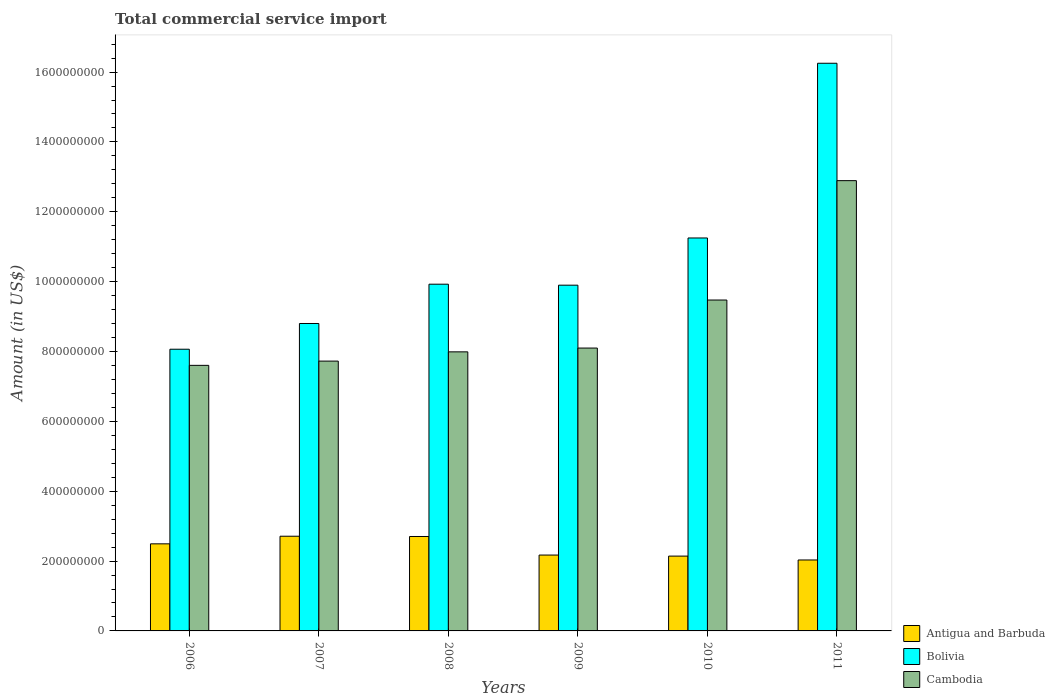How many different coloured bars are there?
Ensure brevity in your answer.  3. How many bars are there on the 5th tick from the left?
Your answer should be very brief. 3. What is the total commercial service import in Bolivia in 2006?
Offer a very short reply. 8.07e+08. Across all years, what is the maximum total commercial service import in Cambodia?
Offer a very short reply. 1.29e+09. Across all years, what is the minimum total commercial service import in Bolivia?
Make the answer very short. 8.07e+08. In which year was the total commercial service import in Bolivia maximum?
Your answer should be compact. 2011. In which year was the total commercial service import in Antigua and Barbuda minimum?
Your response must be concise. 2011. What is the total total commercial service import in Cambodia in the graph?
Give a very brief answer. 5.38e+09. What is the difference between the total commercial service import in Cambodia in 2009 and that in 2011?
Your response must be concise. -4.79e+08. What is the difference between the total commercial service import in Antigua and Barbuda in 2008 and the total commercial service import in Bolivia in 2011?
Make the answer very short. -1.35e+09. What is the average total commercial service import in Bolivia per year?
Provide a succinct answer. 1.07e+09. In the year 2006, what is the difference between the total commercial service import in Antigua and Barbuda and total commercial service import in Cambodia?
Offer a terse response. -5.11e+08. In how many years, is the total commercial service import in Bolivia greater than 1400000000 US$?
Make the answer very short. 1. What is the ratio of the total commercial service import in Bolivia in 2009 to that in 2010?
Your answer should be compact. 0.88. Is the difference between the total commercial service import in Antigua and Barbuda in 2008 and 2009 greater than the difference between the total commercial service import in Cambodia in 2008 and 2009?
Keep it short and to the point. Yes. What is the difference between the highest and the second highest total commercial service import in Antigua and Barbuda?
Your answer should be very brief. 7.73e+05. What is the difference between the highest and the lowest total commercial service import in Bolivia?
Keep it short and to the point. 8.19e+08. In how many years, is the total commercial service import in Bolivia greater than the average total commercial service import in Bolivia taken over all years?
Provide a short and direct response. 2. What does the 3rd bar from the left in 2008 represents?
Provide a succinct answer. Cambodia. What does the 1st bar from the right in 2010 represents?
Provide a succinct answer. Cambodia. Is it the case that in every year, the sum of the total commercial service import in Cambodia and total commercial service import in Bolivia is greater than the total commercial service import in Antigua and Barbuda?
Keep it short and to the point. Yes. Are all the bars in the graph horizontal?
Ensure brevity in your answer.  No. What is the difference between two consecutive major ticks on the Y-axis?
Your answer should be very brief. 2.00e+08. Are the values on the major ticks of Y-axis written in scientific E-notation?
Give a very brief answer. No. How many legend labels are there?
Provide a short and direct response. 3. How are the legend labels stacked?
Keep it short and to the point. Vertical. What is the title of the graph?
Provide a succinct answer. Total commercial service import. What is the label or title of the Y-axis?
Offer a terse response. Amount (in US$). What is the Amount (in US$) in Antigua and Barbuda in 2006?
Keep it short and to the point. 2.49e+08. What is the Amount (in US$) of Bolivia in 2006?
Ensure brevity in your answer.  8.07e+08. What is the Amount (in US$) of Cambodia in 2006?
Provide a short and direct response. 7.60e+08. What is the Amount (in US$) in Antigua and Barbuda in 2007?
Offer a terse response. 2.71e+08. What is the Amount (in US$) of Bolivia in 2007?
Your answer should be compact. 8.80e+08. What is the Amount (in US$) of Cambodia in 2007?
Offer a very short reply. 7.72e+08. What is the Amount (in US$) in Antigua and Barbuda in 2008?
Your response must be concise. 2.70e+08. What is the Amount (in US$) in Bolivia in 2008?
Your answer should be very brief. 9.93e+08. What is the Amount (in US$) of Cambodia in 2008?
Offer a very short reply. 7.99e+08. What is the Amount (in US$) of Antigua and Barbuda in 2009?
Your response must be concise. 2.17e+08. What is the Amount (in US$) of Bolivia in 2009?
Your response must be concise. 9.90e+08. What is the Amount (in US$) in Cambodia in 2009?
Your answer should be compact. 8.10e+08. What is the Amount (in US$) of Antigua and Barbuda in 2010?
Your response must be concise. 2.14e+08. What is the Amount (in US$) of Bolivia in 2010?
Provide a succinct answer. 1.13e+09. What is the Amount (in US$) in Cambodia in 2010?
Offer a very short reply. 9.47e+08. What is the Amount (in US$) in Antigua and Barbuda in 2011?
Provide a short and direct response. 2.03e+08. What is the Amount (in US$) in Bolivia in 2011?
Make the answer very short. 1.63e+09. What is the Amount (in US$) in Cambodia in 2011?
Your answer should be compact. 1.29e+09. Across all years, what is the maximum Amount (in US$) in Antigua and Barbuda?
Your answer should be very brief. 2.71e+08. Across all years, what is the maximum Amount (in US$) in Bolivia?
Make the answer very short. 1.63e+09. Across all years, what is the maximum Amount (in US$) of Cambodia?
Ensure brevity in your answer.  1.29e+09. Across all years, what is the minimum Amount (in US$) in Antigua and Barbuda?
Your response must be concise. 2.03e+08. Across all years, what is the minimum Amount (in US$) in Bolivia?
Give a very brief answer. 8.07e+08. Across all years, what is the minimum Amount (in US$) of Cambodia?
Provide a short and direct response. 7.60e+08. What is the total Amount (in US$) in Antigua and Barbuda in the graph?
Your answer should be compact. 1.43e+09. What is the total Amount (in US$) of Bolivia in the graph?
Make the answer very short. 6.42e+09. What is the total Amount (in US$) of Cambodia in the graph?
Give a very brief answer. 5.38e+09. What is the difference between the Amount (in US$) in Antigua and Barbuda in 2006 and that in 2007?
Make the answer very short. -2.18e+07. What is the difference between the Amount (in US$) of Bolivia in 2006 and that in 2007?
Offer a very short reply. -7.36e+07. What is the difference between the Amount (in US$) in Cambodia in 2006 and that in 2007?
Give a very brief answer. -1.21e+07. What is the difference between the Amount (in US$) of Antigua and Barbuda in 2006 and that in 2008?
Offer a very short reply. -2.10e+07. What is the difference between the Amount (in US$) in Bolivia in 2006 and that in 2008?
Your answer should be very brief. -1.86e+08. What is the difference between the Amount (in US$) of Cambodia in 2006 and that in 2008?
Your response must be concise. -3.86e+07. What is the difference between the Amount (in US$) of Antigua and Barbuda in 2006 and that in 2009?
Ensure brevity in your answer.  3.21e+07. What is the difference between the Amount (in US$) in Bolivia in 2006 and that in 2009?
Give a very brief answer. -1.83e+08. What is the difference between the Amount (in US$) of Cambodia in 2006 and that in 2009?
Offer a very short reply. -4.95e+07. What is the difference between the Amount (in US$) in Antigua and Barbuda in 2006 and that in 2010?
Offer a very short reply. 3.51e+07. What is the difference between the Amount (in US$) in Bolivia in 2006 and that in 2010?
Provide a succinct answer. -3.18e+08. What is the difference between the Amount (in US$) in Cambodia in 2006 and that in 2010?
Keep it short and to the point. -1.87e+08. What is the difference between the Amount (in US$) in Antigua and Barbuda in 2006 and that in 2011?
Offer a terse response. 4.62e+07. What is the difference between the Amount (in US$) of Bolivia in 2006 and that in 2011?
Give a very brief answer. -8.19e+08. What is the difference between the Amount (in US$) of Cambodia in 2006 and that in 2011?
Your answer should be compact. -5.29e+08. What is the difference between the Amount (in US$) of Antigua and Barbuda in 2007 and that in 2008?
Keep it short and to the point. 7.73e+05. What is the difference between the Amount (in US$) of Bolivia in 2007 and that in 2008?
Offer a terse response. -1.13e+08. What is the difference between the Amount (in US$) of Cambodia in 2007 and that in 2008?
Provide a short and direct response. -2.65e+07. What is the difference between the Amount (in US$) in Antigua and Barbuda in 2007 and that in 2009?
Your response must be concise. 5.39e+07. What is the difference between the Amount (in US$) of Bolivia in 2007 and that in 2009?
Ensure brevity in your answer.  -1.10e+08. What is the difference between the Amount (in US$) in Cambodia in 2007 and that in 2009?
Offer a terse response. -3.74e+07. What is the difference between the Amount (in US$) in Antigua and Barbuda in 2007 and that in 2010?
Your answer should be compact. 5.69e+07. What is the difference between the Amount (in US$) in Bolivia in 2007 and that in 2010?
Keep it short and to the point. -2.45e+08. What is the difference between the Amount (in US$) of Cambodia in 2007 and that in 2010?
Ensure brevity in your answer.  -1.75e+08. What is the difference between the Amount (in US$) of Antigua and Barbuda in 2007 and that in 2011?
Offer a very short reply. 6.80e+07. What is the difference between the Amount (in US$) of Bolivia in 2007 and that in 2011?
Give a very brief answer. -7.45e+08. What is the difference between the Amount (in US$) of Cambodia in 2007 and that in 2011?
Give a very brief answer. -5.17e+08. What is the difference between the Amount (in US$) in Antigua and Barbuda in 2008 and that in 2009?
Your answer should be very brief. 5.31e+07. What is the difference between the Amount (in US$) in Bolivia in 2008 and that in 2009?
Your answer should be compact. 2.86e+06. What is the difference between the Amount (in US$) of Cambodia in 2008 and that in 2009?
Ensure brevity in your answer.  -1.09e+07. What is the difference between the Amount (in US$) in Antigua and Barbuda in 2008 and that in 2010?
Make the answer very short. 5.61e+07. What is the difference between the Amount (in US$) in Bolivia in 2008 and that in 2010?
Offer a terse response. -1.32e+08. What is the difference between the Amount (in US$) in Cambodia in 2008 and that in 2010?
Your answer should be compact. -1.48e+08. What is the difference between the Amount (in US$) in Antigua and Barbuda in 2008 and that in 2011?
Offer a very short reply. 6.72e+07. What is the difference between the Amount (in US$) in Bolivia in 2008 and that in 2011?
Give a very brief answer. -6.33e+08. What is the difference between the Amount (in US$) of Cambodia in 2008 and that in 2011?
Provide a succinct answer. -4.90e+08. What is the difference between the Amount (in US$) of Antigua and Barbuda in 2009 and that in 2010?
Provide a succinct answer. 2.99e+06. What is the difference between the Amount (in US$) of Bolivia in 2009 and that in 2010?
Offer a terse response. -1.35e+08. What is the difference between the Amount (in US$) of Cambodia in 2009 and that in 2010?
Ensure brevity in your answer.  -1.38e+08. What is the difference between the Amount (in US$) in Antigua and Barbuda in 2009 and that in 2011?
Keep it short and to the point. 1.41e+07. What is the difference between the Amount (in US$) in Bolivia in 2009 and that in 2011?
Your answer should be compact. -6.35e+08. What is the difference between the Amount (in US$) in Cambodia in 2009 and that in 2011?
Your answer should be compact. -4.79e+08. What is the difference between the Amount (in US$) in Antigua and Barbuda in 2010 and that in 2011?
Your answer should be compact. 1.11e+07. What is the difference between the Amount (in US$) of Bolivia in 2010 and that in 2011?
Provide a succinct answer. -5.00e+08. What is the difference between the Amount (in US$) in Cambodia in 2010 and that in 2011?
Give a very brief answer. -3.42e+08. What is the difference between the Amount (in US$) of Antigua and Barbuda in 2006 and the Amount (in US$) of Bolivia in 2007?
Your response must be concise. -6.31e+08. What is the difference between the Amount (in US$) in Antigua and Barbuda in 2006 and the Amount (in US$) in Cambodia in 2007?
Offer a terse response. -5.23e+08. What is the difference between the Amount (in US$) in Bolivia in 2006 and the Amount (in US$) in Cambodia in 2007?
Your answer should be very brief. 3.40e+07. What is the difference between the Amount (in US$) in Antigua and Barbuda in 2006 and the Amount (in US$) in Bolivia in 2008?
Give a very brief answer. -7.43e+08. What is the difference between the Amount (in US$) of Antigua and Barbuda in 2006 and the Amount (in US$) of Cambodia in 2008?
Your answer should be compact. -5.50e+08. What is the difference between the Amount (in US$) in Bolivia in 2006 and the Amount (in US$) in Cambodia in 2008?
Your response must be concise. 7.52e+06. What is the difference between the Amount (in US$) in Antigua and Barbuda in 2006 and the Amount (in US$) in Bolivia in 2009?
Make the answer very short. -7.41e+08. What is the difference between the Amount (in US$) in Antigua and Barbuda in 2006 and the Amount (in US$) in Cambodia in 2009?
Make the answer very short. -5.61e+08. What is the difference between the Amount (in US$) of Bolivia in 2006 and the Amount (in US$) of Cambodia in 2009?
Make the answer very short. -3.36e+06. What is the difference between the Amount (in US$) in Antigua and Barbuda in 2006 and the Amount (in US$) in Bolivia in 2010?
Your answer should be compact. -8.76e+08. What is the difference between the Amount (in US$) of Antigua and Barbuda in 2006 and the Amount (in US$) of Cambodia in 2010?
Your answer should be very brief. -6.98e+08. What is the difference between the Amount (in US$) of Bolivia in 2006 and the Amount (in US$) of Cambodia in 2010?
Your response must be concise. -1.41e+08. What is the difference between the Amount (in US$) in Antigua and Barbuda in 2006 and the Amount (in US$) in Bolivia in 2011?
Give a very brief answer. -1.38e+09. What is the difference between the Amount (in US$) of Antigua and Barbuda in 2006 and the Amount (in US$) of Cambodia in 2011?
Provide a short and direct response. -1.04e+09. What is the difference between the Amount (in US$) of Bolivia in 2006 and the Amount (in US$) of Cambodia in 2011?
Give a very brief answer. -4.83e+08. What is the difference between the Amount (in US$) of Antigua and Barbuda in 2007 and the Amount (in US$) of Bolivia in 2008?
Provide a succinct answer. -7.22e+08. What is the difference between the Amount (in US$) of Antigua and Barbuda in 2007 and the Amount (in US$) of Cambodia in 2008?
Offer a terse response. -5.28e+08. What is the difference between the Amount (in US$) in Bolivia in 2007 and the Amount (in US$) in Cambodia in 2008?
Keep it short and to the point. 8.12e+07. What is the difference between the Amount (in US$) in Antigua and Barbuda in 2007 and the Amount (in US$) in Bolivia in 2009?
Offer a terse response. -7.19e+08. What is the difference between the Amount (in US$) in Antigua and Barbuda in 2007 and the Amount (in US$) in Cambodia in 2009?
Ensure brevity in your answer.  -5.39e+08. What is the difference between the Amount (in US$) in Bolivia in 2007 and the Amount (in US$) in Cambodia in 2009?
Make the answer very short. 7.03e+07. What is the difference between the Amount (in US$) in Antigua and Barbuda in 2007 and the Amount (in US$) in Bolivia in 2010?
Ensure brevity in your answer.  -8.54e+08. What is the difference between the Amount (in US$) of Antigua and Barbuda in 2007 and the Amount (in US$) of Cambodia in 2010?
Offer a terse response. -6.76e+08. What is the difference between the Amount (in US$) in Bolivia in 2007 and the Amount (in US$) in Cambodia in 2010?
Your answer should be very brief. -6.72e+07. What is the difference between the Amount (in US$) of Antigua and Barbuda in 2007 and the Amount (in US$) of Bolivia in 2011?
Provide a succinct answer. -1.35e+09. What is the difference between the Amount (in US$) in Antigua and Barbuda in 2007 and the Amount (in US$) in Cambodia in 2011?
Your response must be concise. -1.02e+09. What is the difference between the Amount (in US$) of Bolivia in 2007 and the Amount (in US$) of Cambodia in 2011?
Give a very brief answer. -4.09e+08. What is the difference between the Amount (in US$) in Antigua and Barbuda in 2008 and the Amount (in US$) in Bolivia in 2009?
Offer a very short reply. -7.20e+08. What is the difference between the Amount (in US$) of Antigua and Barbuda in 2008 and the Amount (in US$) of Cambodia in 2009?
Offer a terse response. -5.40e+08. What is the difference between the Amount (in US$) in Bolivia in 2008 and the Amount (in US$) in Cambodia in 2009?
Offer a terse response. 1.83e+08. What is the difference between the Amount (in US$) of Antigua and Barbuda in 2008 and the Amount (in US$) of Bolivia in 2010?
Keep it short and to the point. -8.55e+08. What is the difference between the Amount (in US$) in Antigua and Barbuda in 2008 and the Amount (in US$) in Cambodia in 2010?
Give a very brief answer. -6.77e+08. What is the difference between the Amount (in US$) in Bolivia in 2008 and the Amount (in US$) in Cambodia in 2010?
Offer a very short reply. 4.53e+07. What is the difference between the Amount (in US$) of Antigua and Barbuda in 2008 and the Amount (in US$) of Bolivia in 2011?
Provide a succinct answer. -1.35e+09. What is the difference between the Amount (in US$) in Antigua and Barbuda in 2008 and the Amount (in US$) in Cambodia in 2011?
Offer a very short reply. -1.02e+09. What is the difference between the Amount (in US$) in Bolivia in 2008 and the Amount (in US$) in Cambodia in 2011?
Keep it short and to the point. -2.96e+08. What is the difference between the Amount (in US$) in Antigua and Barbuda in 2009 and the Amount (in US$) in Bolivia in 2010?
Your answer should be compact. -9.08e+08. What is the difference between the Amount (in US$) in Antigua and Barbuda in 2009 and the Amount (in US$) in Cambodia in 2010?
Ensure brevity in your answer.  -7.30e+08. What is the difference between the Amount (in US$) of Bolivia in 2009 and the Amount (in US$) of Cambodia in 2010?
Make the answer very short. 4.25e+07. What is the difference between the Amount (in US$) in Antigua and Barbuda in 2009 and the Amount (in US$) in Bolivia in 2011?
Your answer should be compact. -1.41e+09. What is the difference between the Amount (in US$) of Antigua and Barbuda in 2009 and the Amount (in US$) of Cambodia in 2011?
Provide a succinct answer. -1.07e+09. What is the difference between the Amount (in US$) of Bolivia in 2009 and the Amount (in US$) of Cambodia in 2011?
Your answer should be very brief. -2.99e+08. What is the difference between the Amount (in US$) of Antigua and Barbuda in 2010 and the Amount (in US$) of Bolivia in 2011?
Your response must be concise. -1.41e+09. What is the difference between the Amount (in US$) in Antigua and Barbuda in 2010 and the Amount (in US$) in Cambodia in 2011?
Your answer should be very brief. -1.07e+09. What is the difference between the Amount (in US$) in Bolivia in 2010 and the Amount (in US$) in Cambodia in 2011?
Your response must be concise. -1.64e+08. What is the average Amount (in US$) of Antigua and Barbuda per year?
Ensure brevity in your answer.  2.38e+08. What is the average Amount (in US$) in Bolivia per year?
Provide a short and direct response. 1.07e+09. What is the average Amount (in US$) in Cambodia per year?
Your response must be concise. 8.96e+08. In the year 2006, what is the difference between the Amount (in US$) of Antigua and Barbuda and Amount (in US$) of Bolivia?
Ensure brevity in your answer.  -5.57e+08. In the year 2006, what is the difference between the Amount (in US$) of Antigua and Barbuda and Amount (in US$) of Cambodia?
Provide a succinct answer. -5.11e+08. In the year 2006, what is the difference between the Amount (in US$) in Bolivia and Amount (in US$) in Cambodia?
Offer a very short reply. 4.62e+07. In the year 2007, what is the difference between the Amount (in US$) in Antigua and Barbuda and Amount (in US$) in Bolivia?
Keep it short and to the point. -6.09e+08. In the year 2007, what is the difference between the Amount (in US$) in Antigua and Barbuda and Amount (in US$) in Cambodia?
Your answer should be very brief. -5.01e+08. In the year 2007, what is the difference between the Amount (in US$) in Bolivia and Amount (in US$) in Cambodia?
Keep it short and to the point. 1.08e+08. In the year 2008, what is the difference between the Amount (in US$) of Antigua and Barbuda and Amount (in US$) of Bolivia?
Offer a terse response. -7.22e+08. In the year 2008, what is the difference between the Amount (in US$) of Antigua and Barbuda and Amount (in US$) of Cambodia?
Offer a very short reply. -5.29e+08. In the year 2008, what is the difference between the Amount (in US$) in Bolivia and Amount (in US$) in Cambodia?
Provide a succinct answer. 1.94e+08. In the year 2009, what is the difference between the Amount (in US$) in Antigua and Barbuda and Amount (in US$) in Bolivia?
Your response must be concise. -7.73e+08. In the year 2009, what is the difference between the Amount (in US$) of Antigua and Barbuda and Amount (in US$) of Cambodia?
Make the answer very short. -5.93e+08. In the year 2009, what is the difference between the Amount (in US$) of Bolivia and Amount (in US$) of Cambodia?
Keep it short and to the point. 1.80e+08. In the year 2010, what is the difference between the Amount (in US$) in Antigua and Barbuda and Amount (in US$) in Bolivia?
Your response must be concise. -9.11e+08. In the year 2010, what is the difference between the Amount (in US$) in Antigua and Barbuda and Amount (in US$) in Cambodia?
Offer a very short reply. -7.33e+08. In the year 2010, what is the difference between the Amount (in US$) of Bolivia and Amount (in US$) of Cambodia?
Provide a succinct answer. 1.78e+08. In the year 2011, what is the difference between the Amount (in US$) of Antigua and Barbuda and Amount (in US$) of Bolivia?
Ensure brevity in your answer.  -1.42e+09. In the year 2011, what is the difference between the Amount (in US$) in Antigua and Barbuda and Amount (in US$) in Cambodia?
Offer a terse response. -1.09e+09. In the year 2011, what is the difference between the Amount (in US$) of Bolivia and Amount (in US$) of Cambodia?
Keep it short and to the point. 3.36e+08. What is the ratio of the Amount (in US$) in Antigua and Barbuda in 2006 to that in 2007?
Provide a succinct answer. 0.92. What is the ratio of the Amount (in US$) of Bolivia in 2006 to that in 2007?
Provide a succinct answer. 0.92. What is the ratio of the Amount (in US$) of Cambodia in 2006 to that in 2007?
Your answer should be very brief. 0.98. What is the ratio of the Amount (in US$) of Antigua and Barbuda in 2006 to that in 2008?
Ensure brevity in your answer.  0.92. What is the ratio of the Amount (in US$) in Bolivia in 2006 to that in 2008?
Ensure brevity in your answer.  0.81. What is the ratio of the Amount (in US$) in Cambodia in 2006 to that in 2008?
Keep it short and to the point. 0.95. What is the ratio of the Amount (in US$) of Antigua and Barbuda in 2006 to that in 2009?
Provide a short and direct response. 1.15. What is the ratio of the Amount (in US$) in Bolivia in 2006 to that in 2009?
Offer a terse response. 0.81. What is the ratio of the Amount (in US$) of Cambodia in 2006 to that in 2009?
Your response must be concise. 0.94. What is the ratio of the Amount (in US$) in Antigua and Barbuda in 2006 to that in 2010?
Provide a short and direct response. 1.16. What is the ratio of the Amount (in US$) of Bolivia in 2006 to that in 2010?
Offer a very short reply. 0.72. What is the ratio of the Amount (in US$) of Cambodia in 2006 to that in 2010?
Make the answer very short. 0.8. What is the ratio of the Amount (in US$) in Antigua and Barbuda in 2006 to that in 2011?
Offer a very short reply. 1.23. What is the ratio of the Amount (in US$) in Bolivia in 2006 to that in 2011?
Keep it short and to the point. 0.5. What is the ratio of the Amount (in US$) of Cambodia in 2006 to that in 2011?
Give a very brief answer. 0.59. What is the ratio of the Amount (in US$) of Bolivia in 2007 to that in 2008?
Your response must be concise. 0.89. What is the ratio of the Amount (in US$) of Cambodia in 2007 to that in 2008?
Your answer should be very brief. 0.97. What is the ratio of the Amount (in US$) of Antigua and Barbuda in 2007 to that in 2009?
Your answer should be compact. 1.25. What is the ratio of the Amount (in US$) of Bolivia in 2007 to that in 2009?
Make the answer very short. 0.89. What is the ratio of the Amount (in US$) of Cambodia in 2007 to that in 2009?
Keep it short and to the point. 0.95. What is the ratio of the Amount (in US$) of Antigua and Barbuda in 2007 to that in 2010?
Offer a terse response. 1.27. What is the ratio of the Amount (in US$) of Bolivia in 2007 to that in 2010?
Offer a terse response. 0.78. What is the ratio of the Amount (in US$) in Cambodia in 2007 to that in 2010?
Offer a very short reply. 0.82. What is the ratio of the Amount (in US$) of Antigua and Barbuda in 2007 to that in 2011?
Offer a terse response. 1.33. What is the ratio of the Amount (in US$) of Bolivia in 2007 to that in 2011?
Offer a very short reply. 0.54. What is the ratio of the Amount (in US$) of Cambodia in 2007 to that in 2011?
Give a very brief answer. 0.6. What is the ratio of the Amount (in US$) of Antigua and Barbuda in 2008 to that in 2009?
Ensure brevity in your answer.  1.24. What is the ratio of the Amount (in US$) of Bolivia in 2008 to that in 2009?
Offer a very short reply. 1. What is the ratio of the Amount (in US$) in Cambodia in 2008 to that in 2009?
Provide a succinct answer. 0.99. What is the ratio of the Amount (in US$) of Antigua and Barbuda in 2008 to that in 2010?
Your response must be concise. 1.26. What is the ratio of the Amount (in US$) of Bolivia in 2008 to that in 2010?
Provide a short and direct response. 0.88. What is the ratio of the Amount (in US$) of Cambodia in 2008 to that in 2010?
Provide a succinct answer. 0.84. What is the ratio of the Amount (in US$) in Antigua and Barbuda in 2008 to that in 2011?
Offer a very short reply. 1.33. What is the ratio of the Amount (in US$) of Bolivia in 2008 to that in 2011?
Your response must be concise. 0.61. What is the ratio of the Amount (in US$) of Cambodia in 2008 to that in 2011?
Offer a terse response. 0.62. What is the ratio of the Amount (in US$) in Antigua and Barbuda in 2009 to that in 2010?
Ensure brevity in your answer.  1.01. What is the ratio of the Amount (in US$) of Bolivia in 2009 to that in 2010?
Provide a short and direct response. 0.88. What is the ratio of the Amount (in US$) of Cambodia in 2009 to that in 2010?
Offer a terse response. 0.85. What is the ratio of the Amount (in US$) in Antigua and Barbuda in 2009 to that in 2011?
Your response must be concise. 1.07. What is the ratio of the Amount (in US$) of Bolivia in 2009 to that in 2011?
Keep it short and to the point. 0.61. What is the ratio of the Amount (in US$) in Cambodia in 2009 to that in 2011?
Provide a short and direct response. 0.63. What is the ratio of the Amount (in US$) of Antigua and Barbuda in 2010 to that in 2011?
Ensure brevity in your answer.  1.05. What is the ratio of the Amount (in US$) in Bolivia in 2010 to that in 2011?
Make the answer very short. 0.69. What is the ratio of the Amount (in US$) of Cambodia in 2010 to that in 2011?
Offer a very short reply. 0.73. What is the difference between the highest and the second highest Amount (in US$) in Antigua and Barbuda?
Ensure brevity in your answer.  7.73e+05. What is the difference between the highest and the second highest Amount (in US$) in Bolivia?
Offer a terse response. 5.00e+08. What is the difference between the highest and the second highest Amount (in US$) in Cambodia?
Offer a terse response. 3.42e+08. What is the difference between the highest and the lowest Amount (in US$) in Antigua and Barbuda?
Offer a very short reply. 6.80e+07. What is the difference between the highest and the lowest Amount (in US$) of Bolivia?
Your response must be concise. 8.19e+08. What is the difference between the highest and the lowest Amount (in US$) of Cambodia?
Provide a succinct answer. 5.29e+08. 